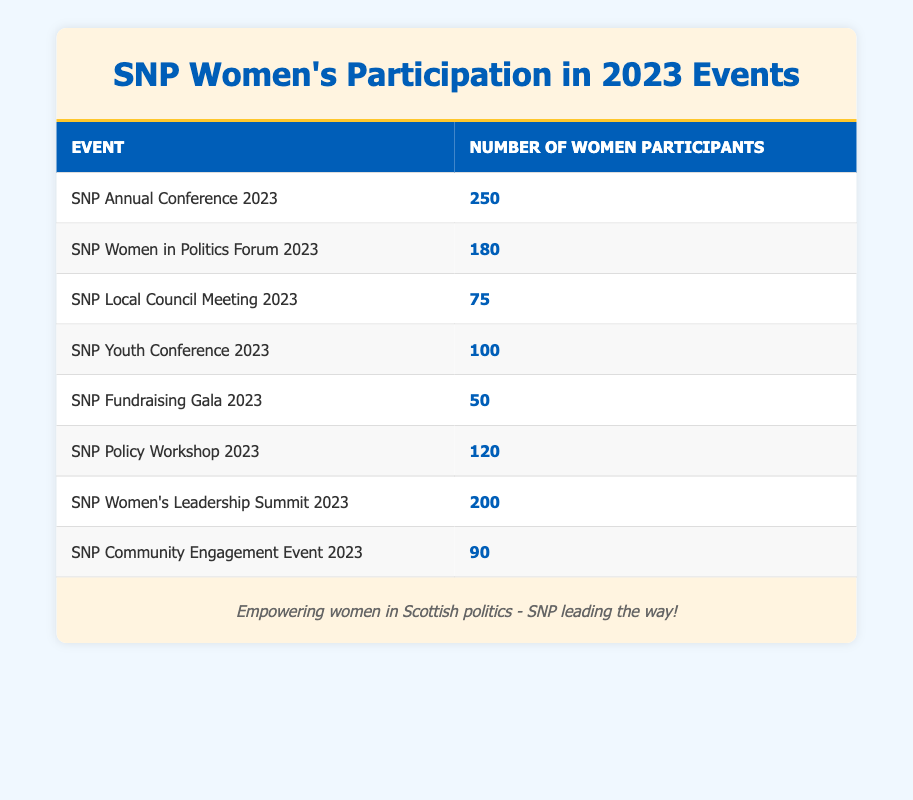What is the highest number of women participants in a single SNP event? The highest number of women participants is found in the "SNP Annual Conference 2023" with 250 attendees.
Answer: 250 Which event had the lowest participation of women? The event with the lowest number of women participants is the "SNP Fundraising Gala 2023," which had 50 women.
Answer: 50 What is the total number of women participants across all SNP events listed? To find the total, we sum all the women participants: 250 + 180 + 75 + 100 + 50 + 120 + 200 + 90 = 1065.
Answer: 1065 What is the average number of women participants in the listed SNP events? First, we calculate the total number of women participants, which is 1065. There are 8 events, so the average is 1065/8 = 133.125. Rounding gives approximately 133.
Answer: 133 Did more women participate in the "SNP Women in Politics Forum 2023" than the "SNP Local Council Meeting 2023"? Yes, the "SNP Women in Politics Forum 2023" had 180 participants, while the "SNP Local Council Meeting 2023" had only 75, confirming more participants in the forum.
Answer: Yes How many more women attended the "SNP Women’s Leadership Summit 2023" compared to the "SNP Youth Conference 2023"? The "SNP Women's Leadership Summit 2023" had 200 participants, and the "SNP Youth Conference 2023" had 100 participants. The difference is 200 - 100 = 100.
Answer: 100 Is the total participation of women in the "SNP Community Engagement Event 2023" and "SNP Policy Workshop 2023" greater than that of the "SNP Annual Conference 2023"? The total for the two events is 90 (Community Engagement) + 120 (Policy Workshop) = 210, which is less than 250 (Annual Conference), confirming the statement is false.
Answer: No Which event saw participation of 180 women participants? The event that had 180 women participants is the "SNP Women in Politics Forum 2023."
Answer: SNP Women in Politics Forum 2023 